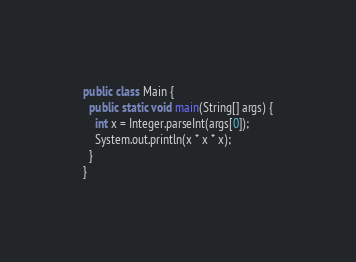<code> <loc_0><loc_0><loc_500><loc_500><_Java_>public class Main {
  public static void main(String[] args) {
    int x = Integer.parseInt(args[0]);
    System.out.println(x * x * x);
  }
}</code> 